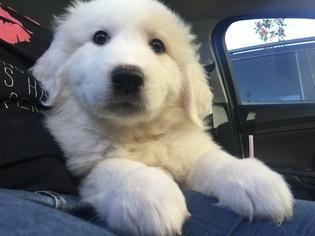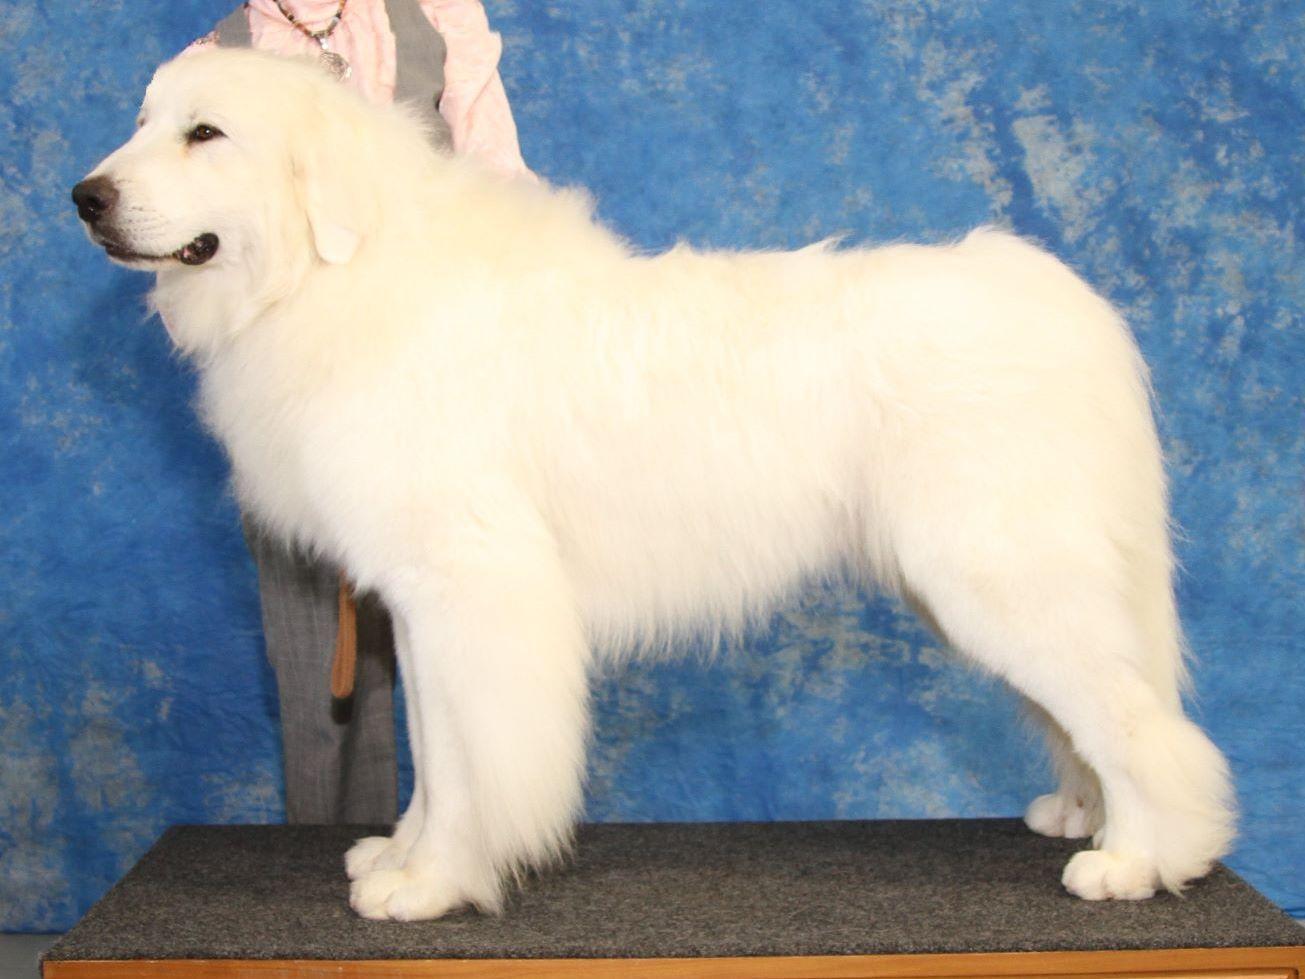The first image is the image on the left, the second image is the image on the right. Evaluate the accuracy of this statement regarding the images: "All of the white dogs are facing leftward, and one dog is posed on green grass.". Is it true? Answer yes or no. No. 